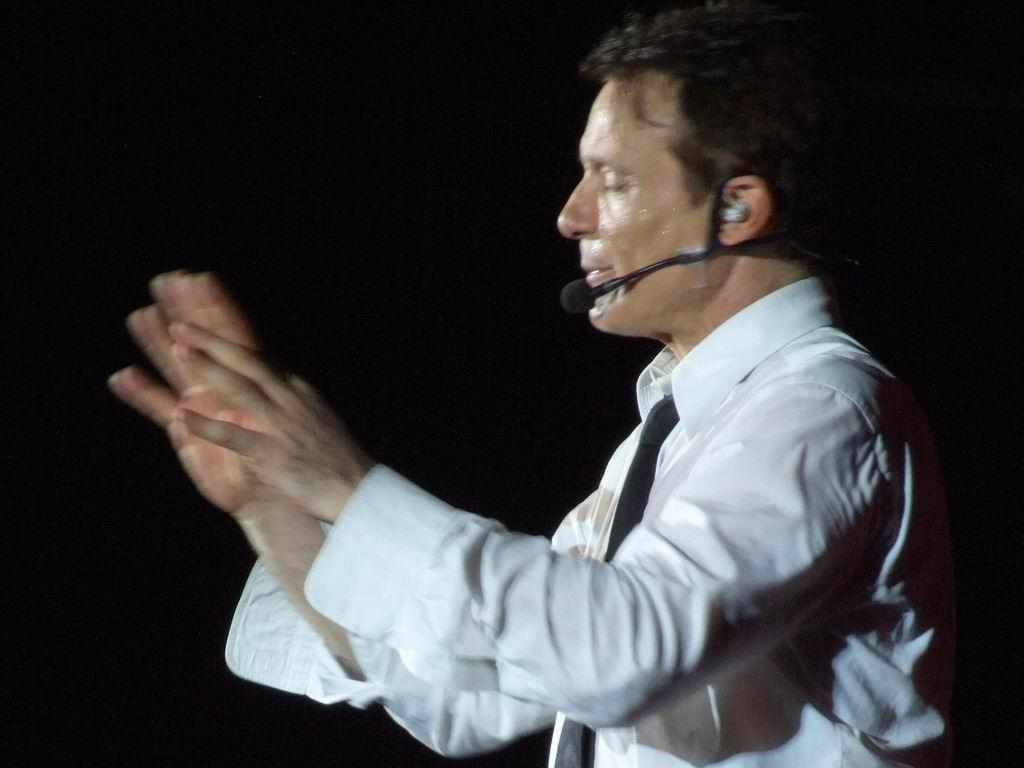Who is the person in the image? There is a man in the image. What is the man wearing on his upper body? The man is wearing a white shirt. What accessory is the man wearing around his neck? The man is wearing a black tie. What is the man doing in the image? The man appears to be talking on a microphone. What is the color of the background in the image? The background of the image is black in color. What type of coil is used in the man's religion in the image? There is no mention of religion or coils in the image, so it is not possible to answer that question. 